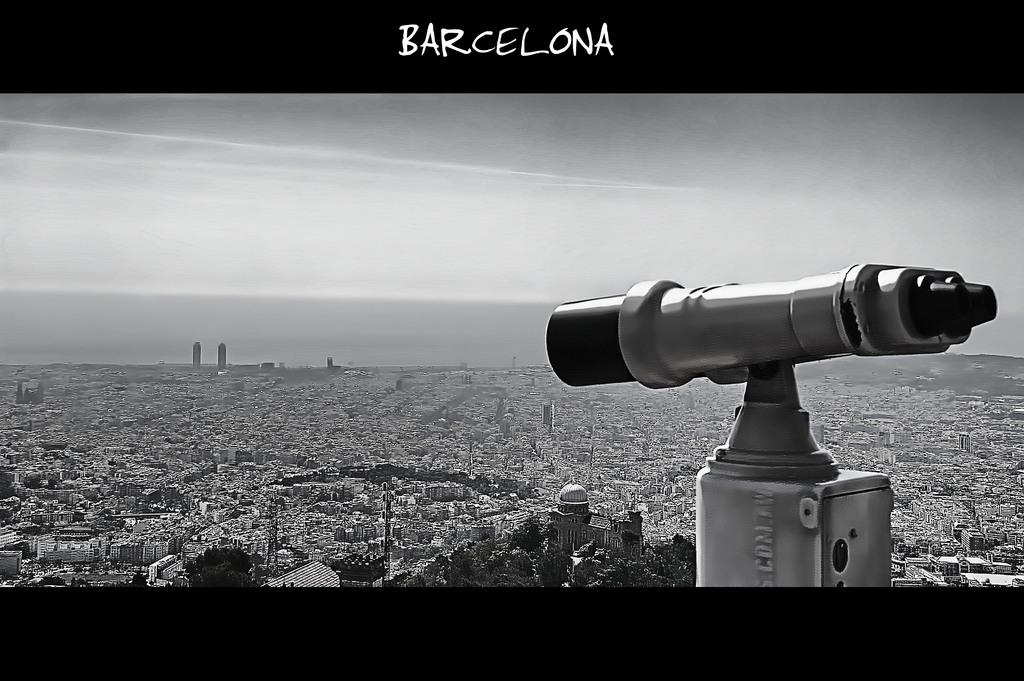What is the main object in the image? There is a telescope in the image. Where is the telescope located in the image? The telescope is in the front of the image. What else can be seen in the image besides the telescope? There are buildings visible in the image, and they are present all over the image. What is the condition of the sky in the image? The sky in the image has clouds. Can you tell me how the bat is flying in the image? There is no bat present in the image; it only features a telescope, buildings, and clouds in the sky. 